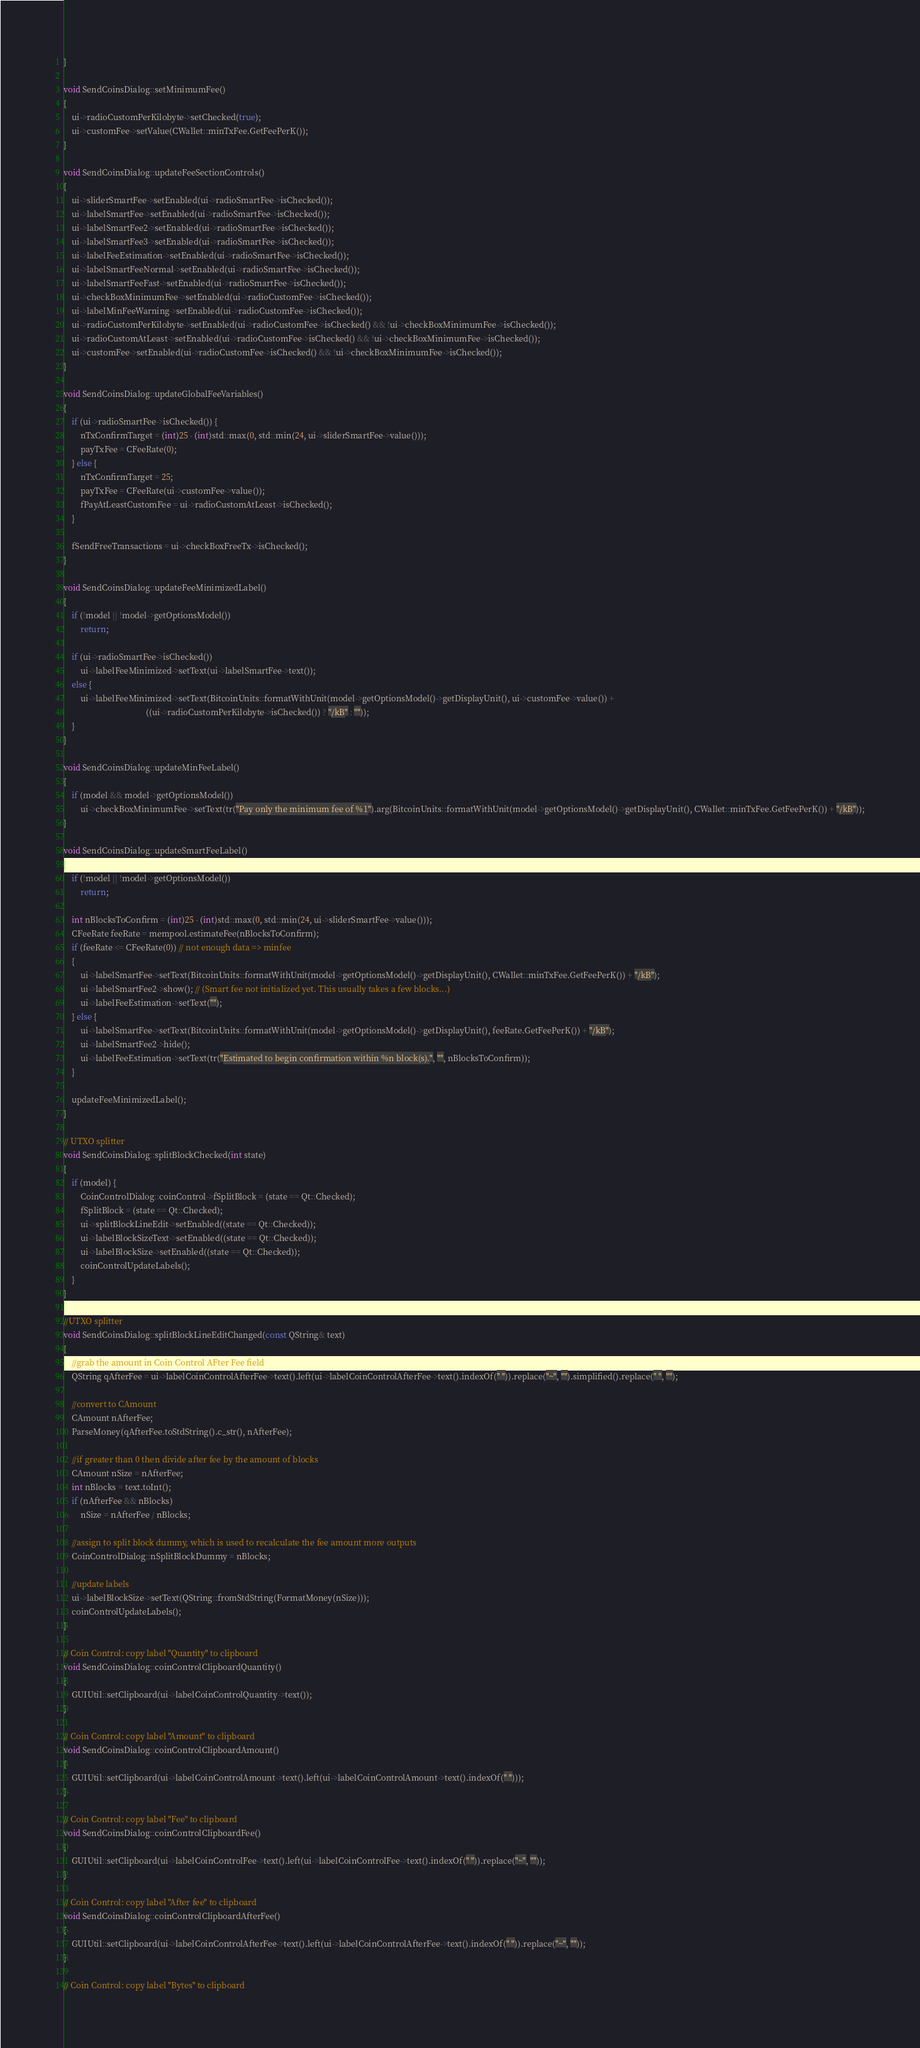<code> <loc_0><loc_0><loc_500><loc_500><_C++_>}

void SendCoinsDialog::setMinimumFee()
{
    ui->radioCustomPerKilobyte->setChecked(true);
    ui->customFee->setValue(CWallet::minTxFee.GetFeePerK());
}

void SendCoinsDialog::updateFeeSectionControls()
{
    ui->sliderSmartFee->setEnabled(ui->radioSmartFee->isChecked());
    ui->labelSmartFee->setEnabled(ui->radioSmartFee->isChecked());
    ui->labelSmartFee2->setEnabled(ui->radioSmartFee->isChecked());
    ui->labelSmartFee3->setEnabled(ui->radioSmartFee->isChecked());
    ui->labelFeeEstimation->setEnabled(ui->radioSmartFee->isChecked());
    ui->labelSmartFeeNormal->setEnabled(ui->radioSmartFee->isChecked());
    ui->labelSmartFeeFast->setEnabled(ui->radioSmartFee->isChecked());
    ui->checkBoxMinimumFee->setEnabled(ui->radioCustomFee->isChecked());
    ui->labelMinFeeWarning->setEnabled(ui->radioCustomFee->isChecked());
    ui->radioCustomPerKilobyte->setEnabled(ui->radioCustomFee->isChecked() && !ui->checkBoxMinimumFee->isChecked());
    ui->radioCustomAtLeast->setEnabled(ui->radioCustomFee->isChecked() && !ui->checkBoxMinimumFee->isChecked());
    ui->customFee->setEnabled(ui->radioCustomFee->isChecked() && !ui->checkBoxMinimumFee->isChecked());
}

void SendCoinsDialog::updateGlobalFeeVariables()
{
    if (ui->radioSmartFee->isChecked()) {
        nTxConfirmTarget = (int)25 - (int)std::max(0, std::min(24, ui->sliderSmartFee->value()));
        payTxFee = CFeeRate(0);
    } else {
        nTxConfirmTarget = 25;
        payTxFee = CFeeRate(ui->customFee->value());
        fPayAtLeastCustomFee = ui->radioCustomAtLeast->isChecked();
    }

    fSendFreeTransactions = ui->checkBoxFreeTx->isChecked();
}

void SendCoinsDialog::updateFeeMinimizedLabel()
{
    if (!model || !model->getOptionsModel())
        return;

    if (ui->radioSmartFee->isChecked())
        ui->labelFeeMinimized->setText(ui->labelSmartFee->text());
    else {
        ui->labelFeeMinimized->setText(BitcoinUnits::formatWithUnit(model->getOptionsModel()->getDisplayUnit(), ui->customFee->value()) +
                                       ((ui->radioCustomPerKilobyte->isChecked()) ? "/kB" : ""));
    }
}

void SendCoinsDialog::updateMinFeeLabel()
{
    if (model && model->getOptionsModel())
        ui->checkBoxMinimumFee->setText(tr("Pay only the minimum fee of %1").arg(BitcoinUnits::formatWithUnit(model->getOptionsModel()->getDisplayUnit(), CWallet::minTxFee.GetFeePerK()) + "/kB"));
}

void SendCoinsDialog::updateSmartFeeLabel()
{
    if (!model || !model->getOptionsModel())
        return;

    int nBlocksToConfirm = (int)25 - (int)std::max(0, std::min(24, ui->sliderSmartFee->value()));
    CFeeRate feeRate = mempool.estimateFee(nBlocksToConfirm);
    if (feeRate <= CFeeRate(0)) // not enough data => minfee
    {
        ui->labelSmartFee->setText(BitcoinUnits::formatWithUnit(model->getOptionsModel()->getDisplayUnit(), CWallet::minTxFee.GetFeePerK()) + "/kB");
        ui->labelSmartFee2->show(); // (Smart fee not initialized yet. This usually takes a few blocks...)
        ui->labelFeeEstimation->setText("");
    } else {
        ui->labelSmartFee->setText(BitcoinUnits::formatWithUnit(model->getOptionsModel()->getDisplayUnit(), feeRate.GetFeePerK()) + "/kB");
        ui->labelSmartFee2->hide();
        ui->labelFeeEstimation->setText(tr("Estimated to begin confirmation within %n block(s).", "", nBlocksToConfirm));
    }

    updateFeeMinimizedLabel();
}

// UTXO splitter
void SendCoinsDialog::splitBlockChecked(int state)
{
    if (model) {
        CoinControlDialog::coinControl->fSplitBlock = (state == Qt::Checked);
        fSplitBlock = (state == Qt::Checked);
        ui->splitBlockLineEdit->setEnabled((state == Qt::Checked));
        ui->labelBlockSizeText->setEnabled((state == Qt::Checked));
        ui->labelBlockSize->setEnabled((state == Qt::Checked));
        coinControlUpdateLabels();
    }
}

//UTXO splitter
void SendCoinsDialog::splitBlockLineEditChanged(const QString& text)
{
    //grab the amount in Coin Control AFter Fee field
    QString qAfterFee = ui->labelCoinControlAfterFee->text().left(ui->labelCoinControlAfterFee->text().indexOf(" ")).replace("~", "").simplified().replace(" ", "");

    //convert to CAmount
    CAmount nAfterFee;
    ParseMoney(qAfterFee.toStdString().c_str(), nAfterFee);

    //if greater than 0 then divide after fee by the amount of blocks
    CAmount nSize = nAfterFee;
    int nBlocks = text.toInt();
    if (nAfterFee && nBlocks)
        nSize = nAfterFee / nBlocks;

    //assign to split block dummy, which is used to recalculate the fee amount more outputs
    CoinControlDialog::nSplitBlockDummy = nBlocks;

    //update labels
    ui->labelBlockSize->setText(QString::fromStdString(FormatMoney(nSize)));
    coinControlUpdateLabels();
}

// Coin Control: copy label "Quantity" to clipboard
void SendCoinsDialog::coinControlClipboardQuantity()
{
    GUIUtil::setClipboard(ui->labelCoinControlQuantity->text());
}

// Coin Control: copy label "Amount" to clipboard
void SendCoinsDialog::coinControlClipboardAmount()
{
    GUIUtil::setClipboard(ui->labelCoinControlAmount->text().left(ui->labelCoinControlAmount->text().indexOf(" ")));
}

// Coin Control: copy label "Fee" to clipboard
void SendCoinsDialog::coinControlClipboardFee()
{
    GUIUtil::setClipboard(ui->labelCoinControlFee->text().left(ui->labelCoinControlFee->text().indexOf(" ")).replace("~", ""));
}

// Coin Control: copy label "After fee" to clipboard
void SendCoinsDialog::coinControlClipboardAfterFee()
{
    GUIUtil::setClipboard(ui->labelCoinControlAfterFee->text().left(ui->labelCoinControlAfterFee->text().indexOf(" ")).replace("~", ""));
}

// Coin Control: copy label "Bytes" to clipboard</code> 